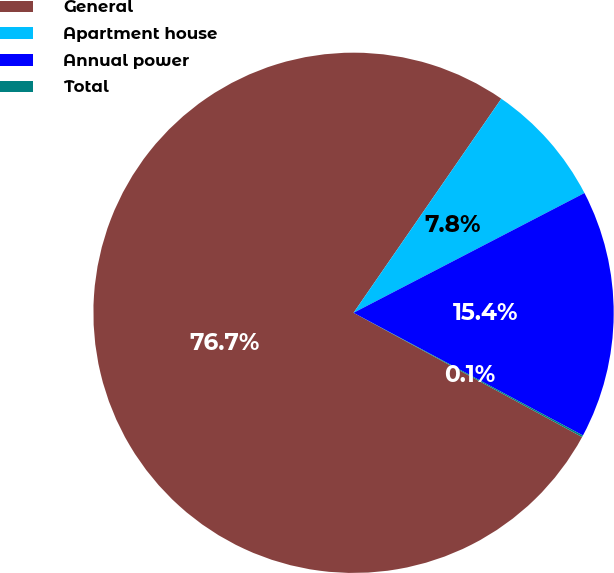<chart> <loc_0><loc_0><loc_500><loc_500><pie_chart><fcel>General<fcel>Apartment house<fcel>Annual power<fcel>Total<nl><fcel>76.69%<fcel>7.77%<fcel>15.43%<fcel>0.11%<nl></chart> 